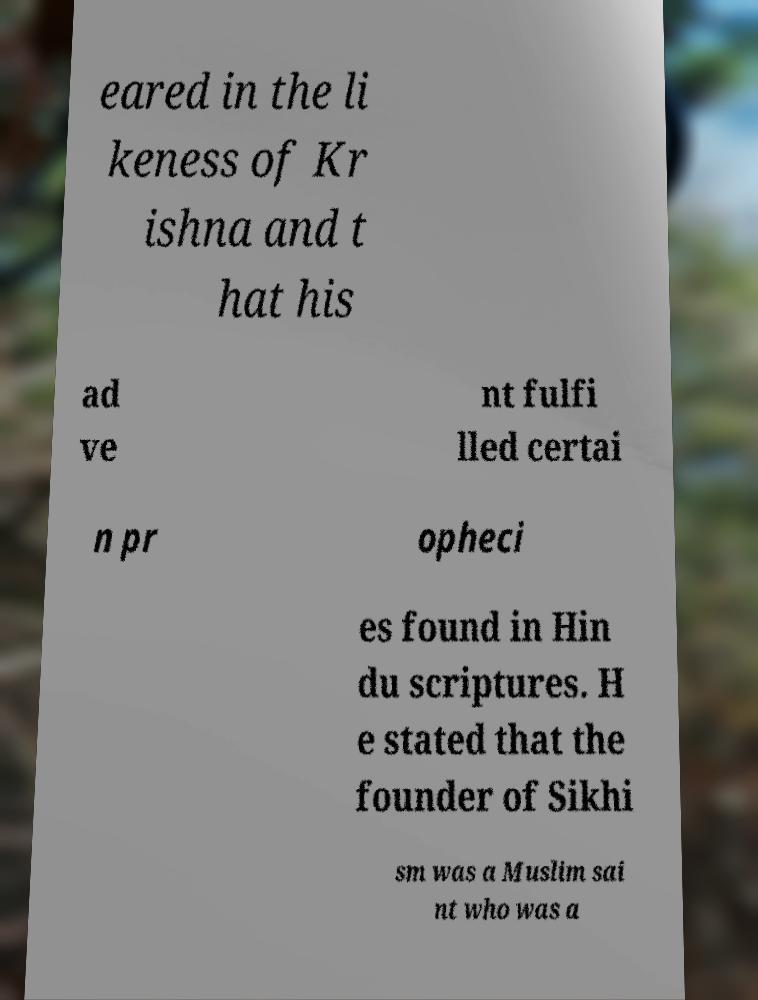Could you extract and type out the text from this image? eared in the li keness of Kr ishna and t hat his ad ve nt fulfi lled certai n pr opheci es found in Hin du scriptures. H e stated that the founder of Sikhi sm was a Muslim sai nt who was a 